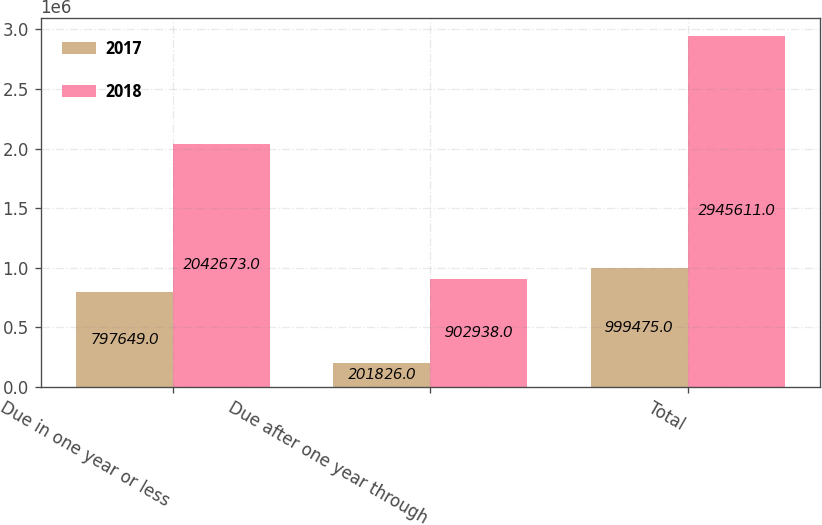Convert chart to OTSL. <chart><loc_0><loc_0><loc_500><loc_500><stacked_bar_chart><ecel><fcel>Due in one year or less<fcel>Due after one year through<fcel>Total<nl><fcel>2017<fcel>797649<fcel>201826<fcel>999475<nl><fcel>2018<fcel>2.04267e+06<fcel>902938<fcel>2.94561e+06<nl></chart> 